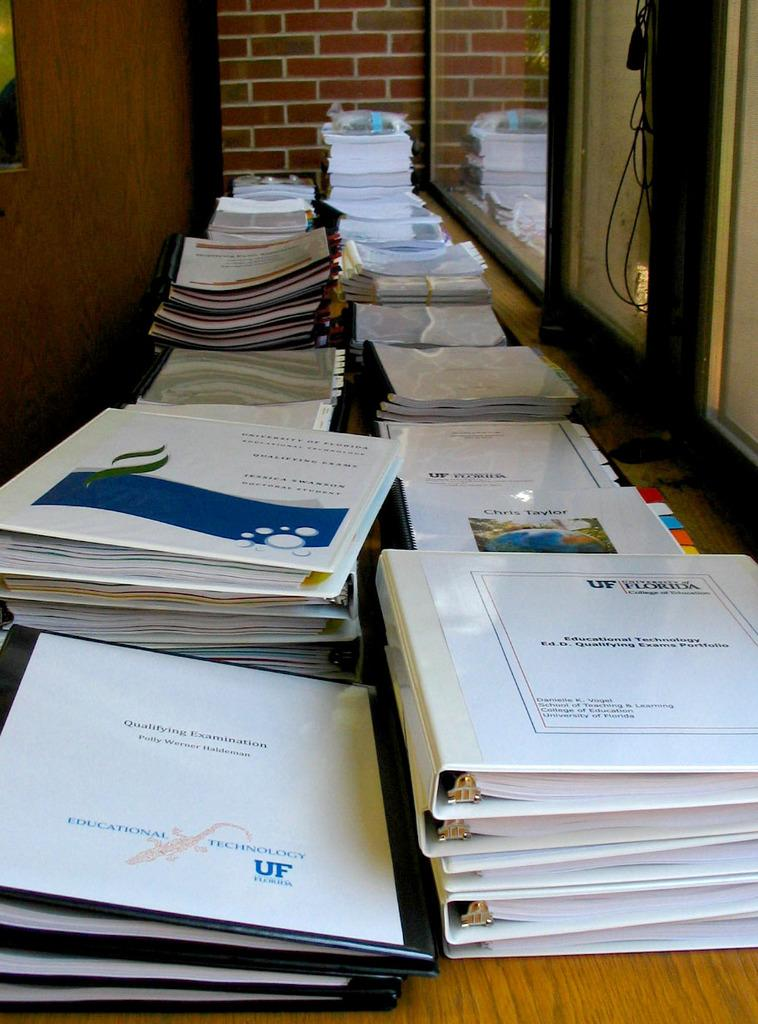<image>
Share a concise interpretation of the image provided. Several notebooks that are from UF Technology with various titles. 